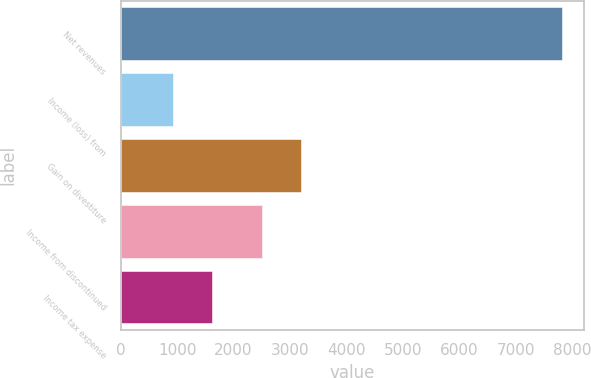<chart> <loc_0><loc_0><loc_500><loc_500><bar_chart><fcel>Net revenues<fcel>Income (loss) from<fcel>Gain on divestiture<fcel>Income from discontinued<fcel>Income tax expense<nl><fcel>7813<fcel>932<fcel>3194.1<fcel>2506<fcel>1620.1<nl></chart> 